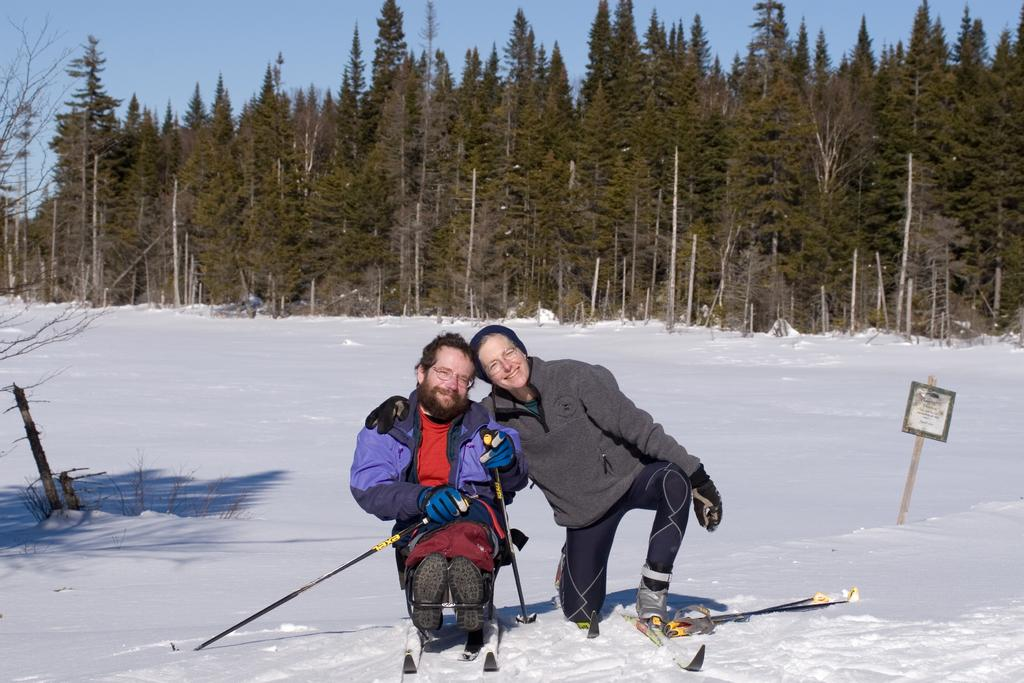What activity is the man in the image engaged in? The man is skiing on the snow. What is the man wearing while skiing? The man is wearing a coat. Who is present beside the man in the image? A woman is present beside the man. What is the woman wearing in the image? The woman is wearing a coat. What is the woman's facial expression in the image? The woman is smiling. What can be seen in the background of the image? There are trees visible at the back side of the image. What type of health issues does the man have while skiing in the image? There is no information about the man's health in the image, so it cannot be determined. Can you tell me where the basin is located in the image? There is no basin present in the image. 